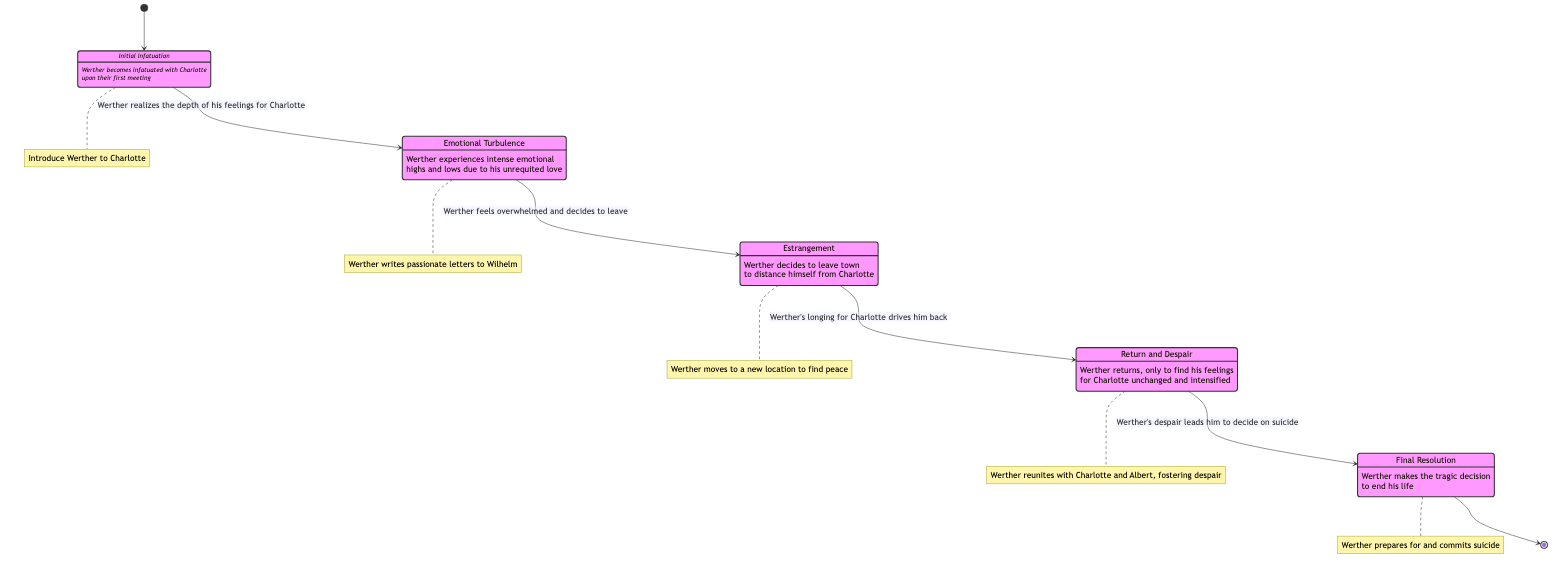What is the first state in the diagram? The first state can be found at the beginning of the diagram leading from the initial state marker to the next state. The transition indicates that the first state is "Initial Infatuation."
Answer: Initial Infatuation How many states are there in total? Counting the states listed in the diagram reveals five distinct states: Initial Infatuation, Emotional Turbulence, Estrangement, Return and Despair, and Final Resolution, so the total is five.
Answer: 5 What is the trigger for the transition from "Initial Infatuation" to "Emotional Turbulence"? The trigger for this transition is explicitly stated in the diagram, where it mentions that "Werther realizes the depth of his feelings for Charlotte" as the reason for this change.
Answer: Werther realizes the depth of his feelings for Charlotte What is the final state in the diagram? The final state is indicated by the last node before the return to the initial state marker. The last state is shown to be "Final Resolution."
Answer: Final Resolution What action is associated with the "Estrangement" state? The specific action related to this state is described in the diagram as "Werther moves to a new location to find peace," indicating what Werther does during this state.
Answer: Werther moves to a new location to find peace What causes the transition from "Return and Despair" to "Final Resolution"? The reason for this transition is given in the diagram, which states that "Werther's despair leads him to decide on suicide" as the motivation for this state change.
Answer: Werther's despair leads him to decide on suicide Which two states are adjacent to "Emotional Turbulence"? The states adjacent to "Emotional Turbulence" are "Initial Infatuation," which precedes it, and "Estrangement," which follows it. This can be inferred from their respective connections.
Answer: Initial Infatuation, Estrangement Describe the emotional theme associated with "Emotional Turbulence." The diagram describes this state as experiencing "intense emotional highs and lows due to his unrequited love," highlighting the nature of Werther's feelings during this time.
Answer: intense emotional highs and lows due to his unrequited love How does "Estrangement" influence Werther's feelings toward Charlotte? In the diagram, "Estrangement" demonstrates that despite his attempt to distance himself from Charlotte, it ultimately leads to a longing that drives him back, indicating that it intensifies his feelings rather than diminishing them.
Answer: it intensifies his feelings 